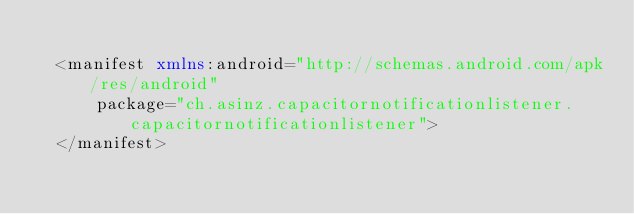<code> <loc_0><loc_0><loc_500><loc_500><_XML_>
  <manifest xmlns:android="http://schemas.android.com/apk/res/android"
      package="ch.asinz.capacitornotificationlistener.capacitornotificationlistener">
  </manifest>
  </code> 